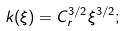<formula> <loc_0><loc_0><loc_500><loc_500>k ( \xi ) = C _ { r } ^ { 3 / 2 } \xi ^ { 3 / 2 } ;</formula> 